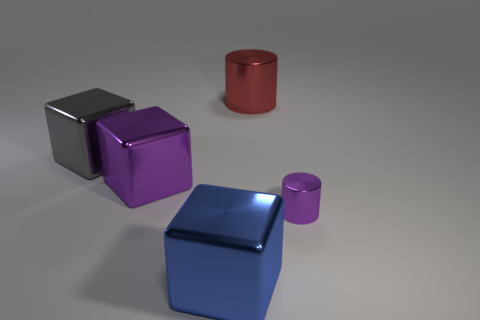Add 5 tiny purple metallic objects. How many objects exist? 10 Subtract all cylinders. How many objects are left? 3 Add 5 big purple objects. How many big purple objects are left? 6 Add 4 big purple metal blocks. How many big purple metal blocks exist? 5 Subtract 0 brown cylinders. How many objects are left? 5 Subtract all big purple objects. Subtract all large gray matte blocks. How many objects are left? 4 